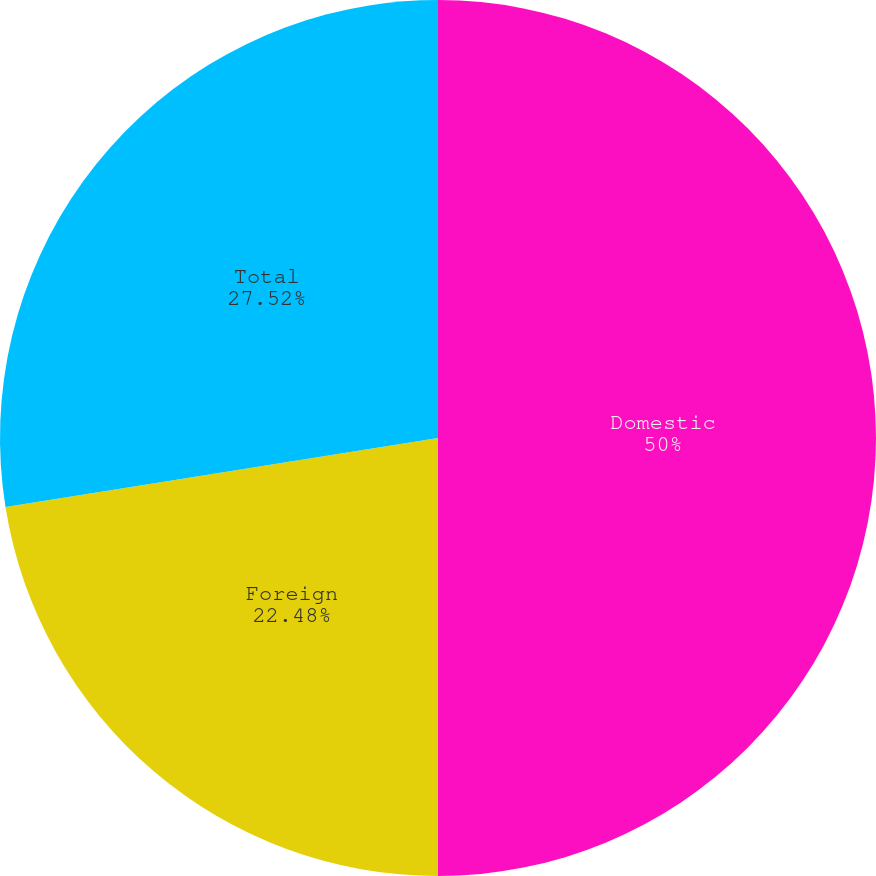Convert chart to OTSL. <chart><loc_0><loc_0><loc_500><loc_500><pie_chart><fcel>Domestic<fcel>Foreign<fcel>Total<nl><fcel>50.0%<fcel>22.48%<fcel>27.52%<nl></chart> 